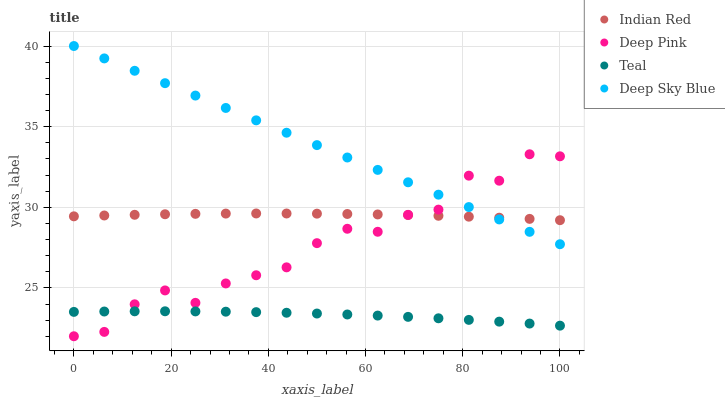Does Teal have the minimum area under the curve?
Answer yes or no. Yes. Does Deep Sky Blue have the maximum area under the curve?
Answer yes or no. Yes. Does Deep Pink have the minimum area under the curve?
Answer yes or no. No. Does Deep Pink have the maximum area under the curve?
Answer yes or no. No. Is Deep Sky Blue the smoothest?
Answer yes or no. Yes. Is Deep Pink the roughest?
Answer yes or no. Yes. Is Teal the smoothest?
Answer yes or no. No. Is Teal the roughest?
Answer yes or no. No. Does Deep Pink have the lowest value?
Answer yes or no. Yes. Does Teal have the lowest value?
Answer yes or no. No. Does Deep Sky Blue have the highest value?
Answer yes or no. Yes. Does Deep Pink have the highest value?
Answer yes or no. No. Is Teal less than Indian Red?
Answer yes or no. Yes. Is Deep Sky Blue greater than Teal?
Answer yes or no. Yes. Does Teal intersect Deep Pink?
Answer yes or no. Yes. Is Teal less than Deep Pink?
Answer yes or no. No. Is Teal greater than Deep Pink?
Answer yes or no. No. Does Teal intersect Indian Red?
Answer yes or no. No. 